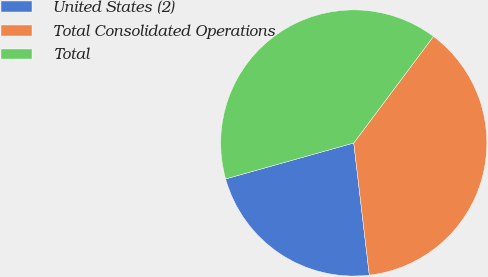Convert chart. <chart><loc_0><loc_0><loc_500><loc_500><pie_chart><fcel>United States (2)<fcel>Total Consolidated Operations<fcel>Total<nl><fcel>22.51%<fcel>37.91%<fcel>39.57%<nl></chart> 